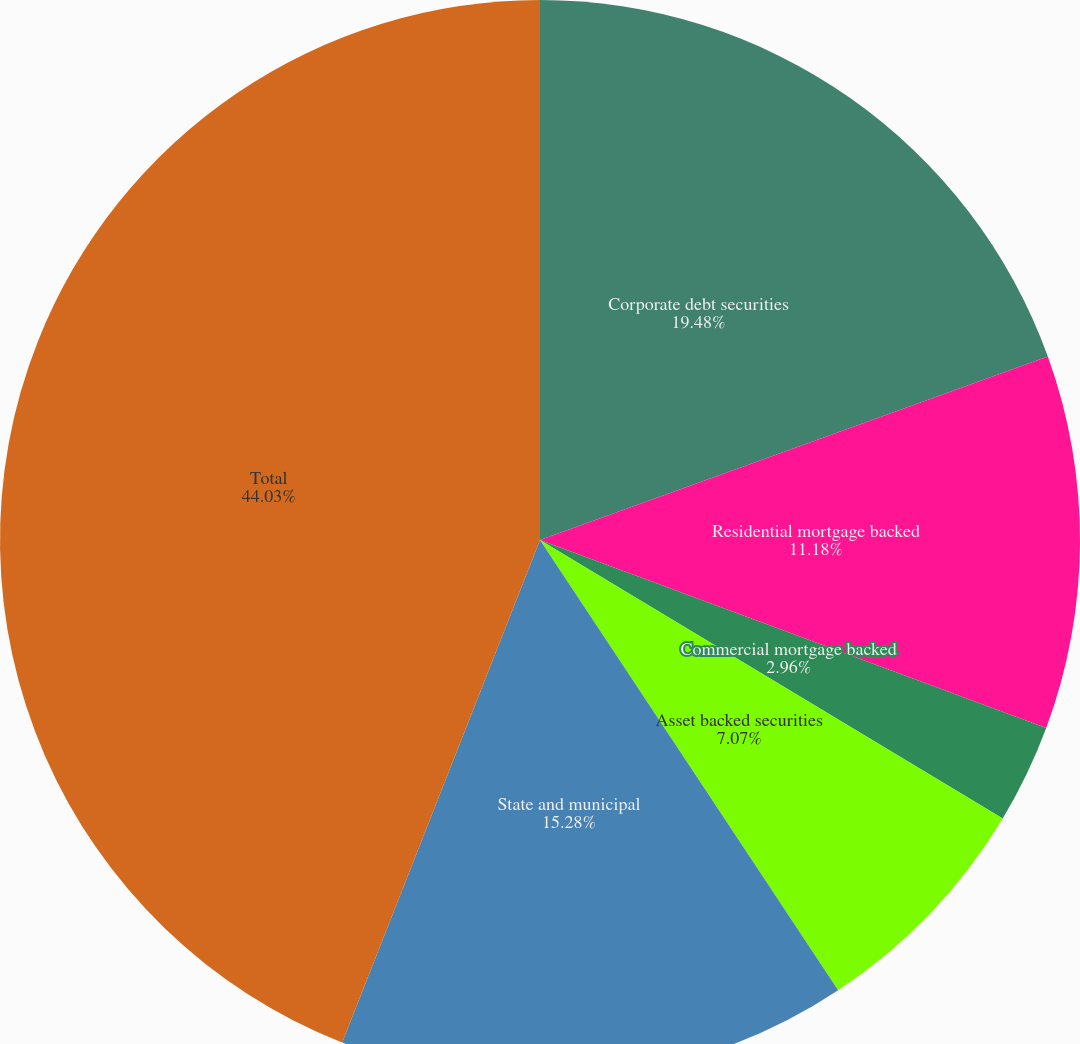<chart> <loc_0><loc_0><loc_500><loc_500><pie_chart><fcel>Corporate debt securities<fcel>Residential mortgage backed<fcel>Commercial mortgage backed<fcel>Asset backed securities<fcel>State and municipal<fcel>Total<nl><fcel>19.48%<fcel>11.18%<fcel>2.96%<fcel>7.07%<fcel>15.28%<fcel>44.03%<nl></chart> 